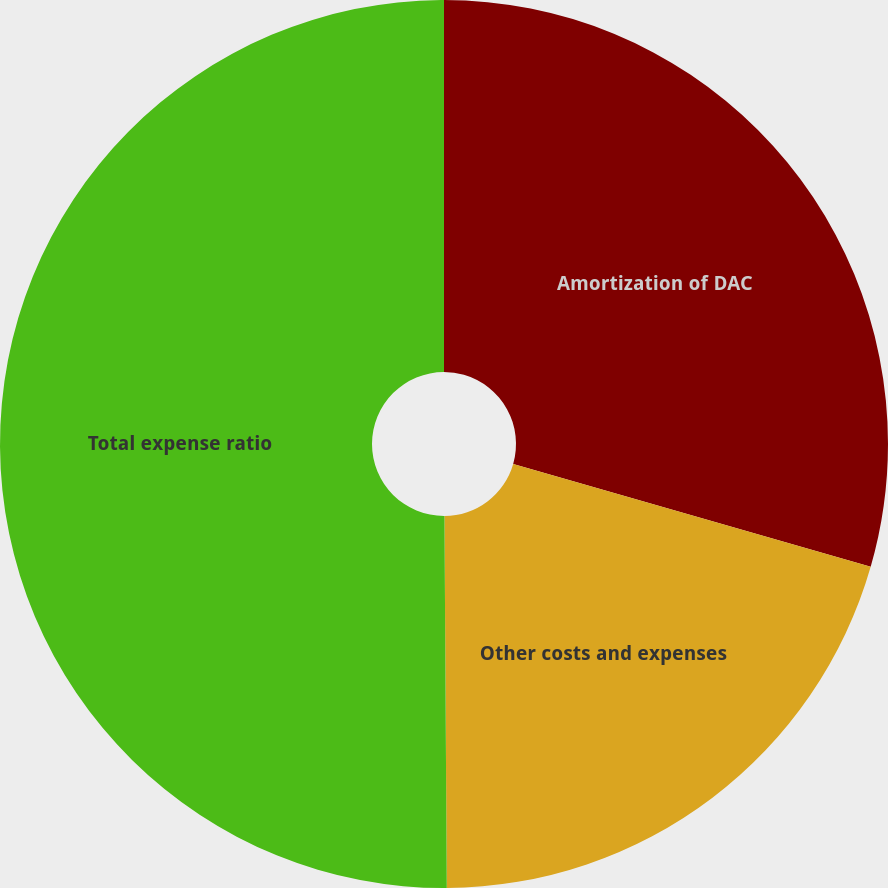Convert chart. <chart><loc_0><loc_0><loc_500><loc_500><pie_chart><fcel>Amortization of DAC<fcel>Other costs and expenses<fcel>Total expense ratio<nl><fcel>29.46%<fcel>20.44%<fcel>50.1%<nl></chart> 